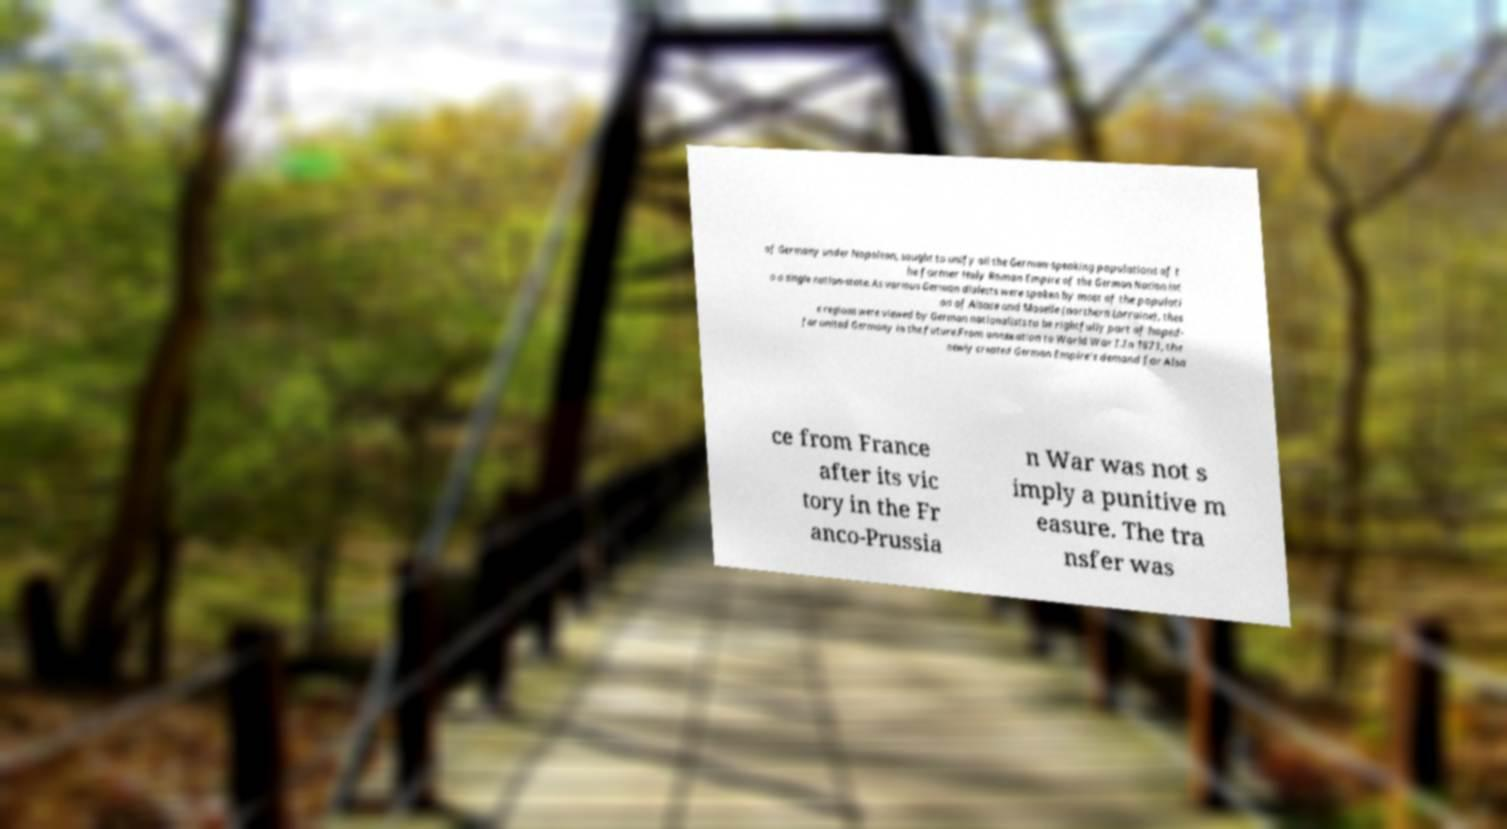Please read and relay the text visible in this image. What does it say? of Germany under Napoleon, sought to unify all the German-speaking populations of t he former Holy Roman Empire of the German Nation int o a single nation-state. As various German dialects were spoken by most of the populati on of Alsace and Moselle (northern Lorraine), thes e regions were viewed by German nationalists to be rightfully part of hoped- for united Germany in the future.From annexation to World War I.In 1871, the newly created German Empire's demand for Alsa ce from France after its vic tory in the Fr anco-Prussia n War was not s imply a punitive m easure. The tra nsfer was 